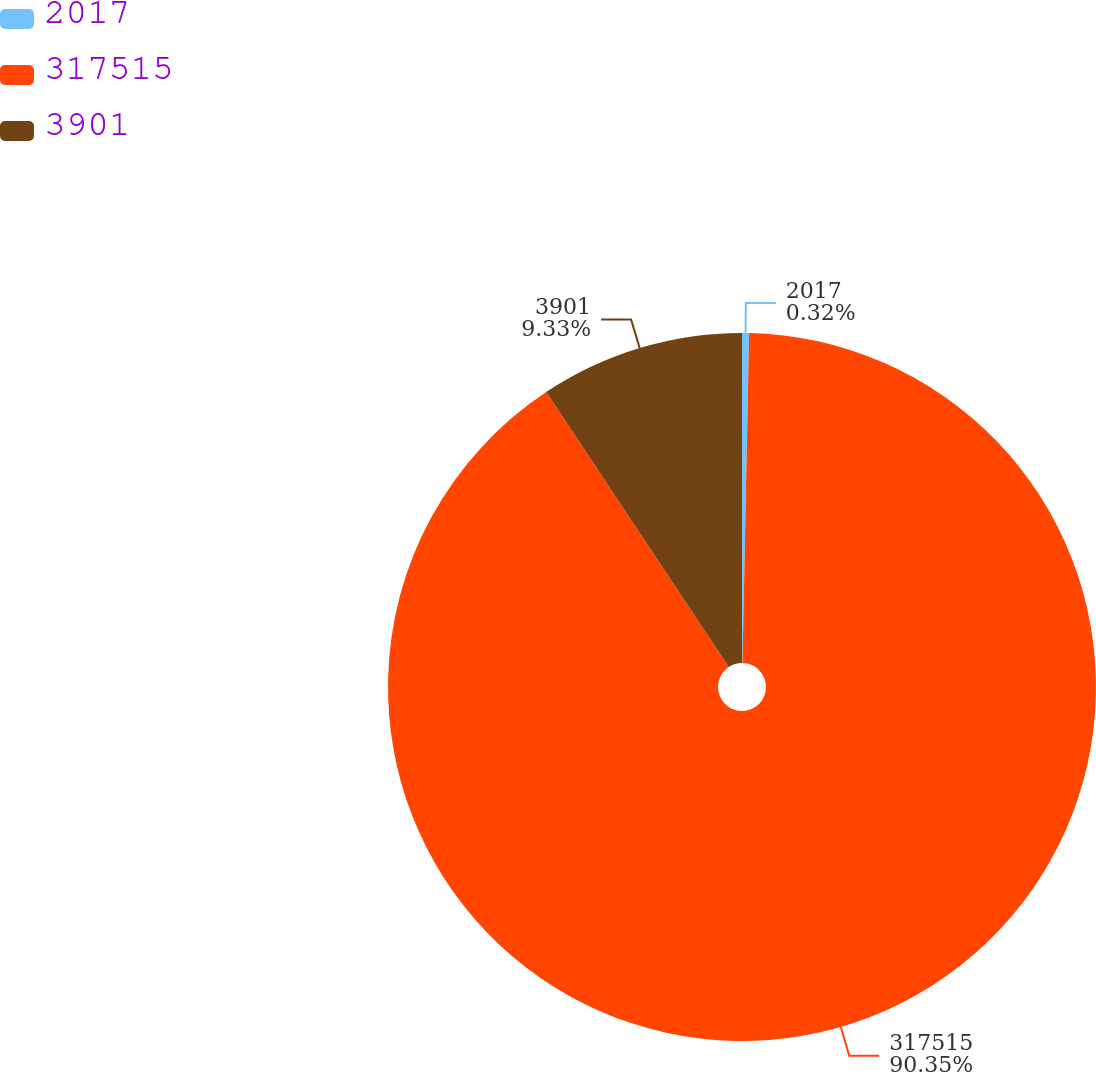Convert chart. <chart><loc_0><loc_0><loc_500><loc_500><pie_chart><fcel>2017<fcel>317515<fcel>3901<nl><fcel>0.32%<fcel>90.35%<fcel>9.33%<nl></chart> 